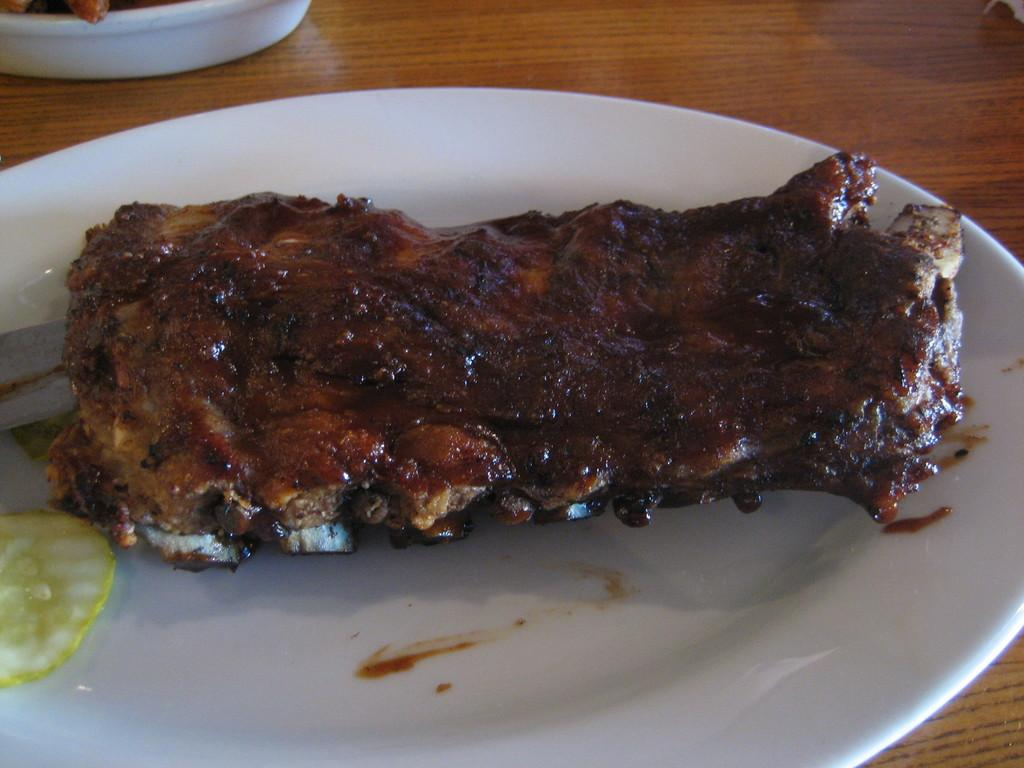What is on the plate that is visible in the image? There is a plate of meat in the image. Where is the plate of meat located? The plate of meat is placed on a table. What type of glue is being used to hold the church together in the image? There is no church or glue present in the image; it features a plate of meat on a table. How many legs can be seen on the leg in the image? There is no leg present in the image; it features a plate of meat on a table. 